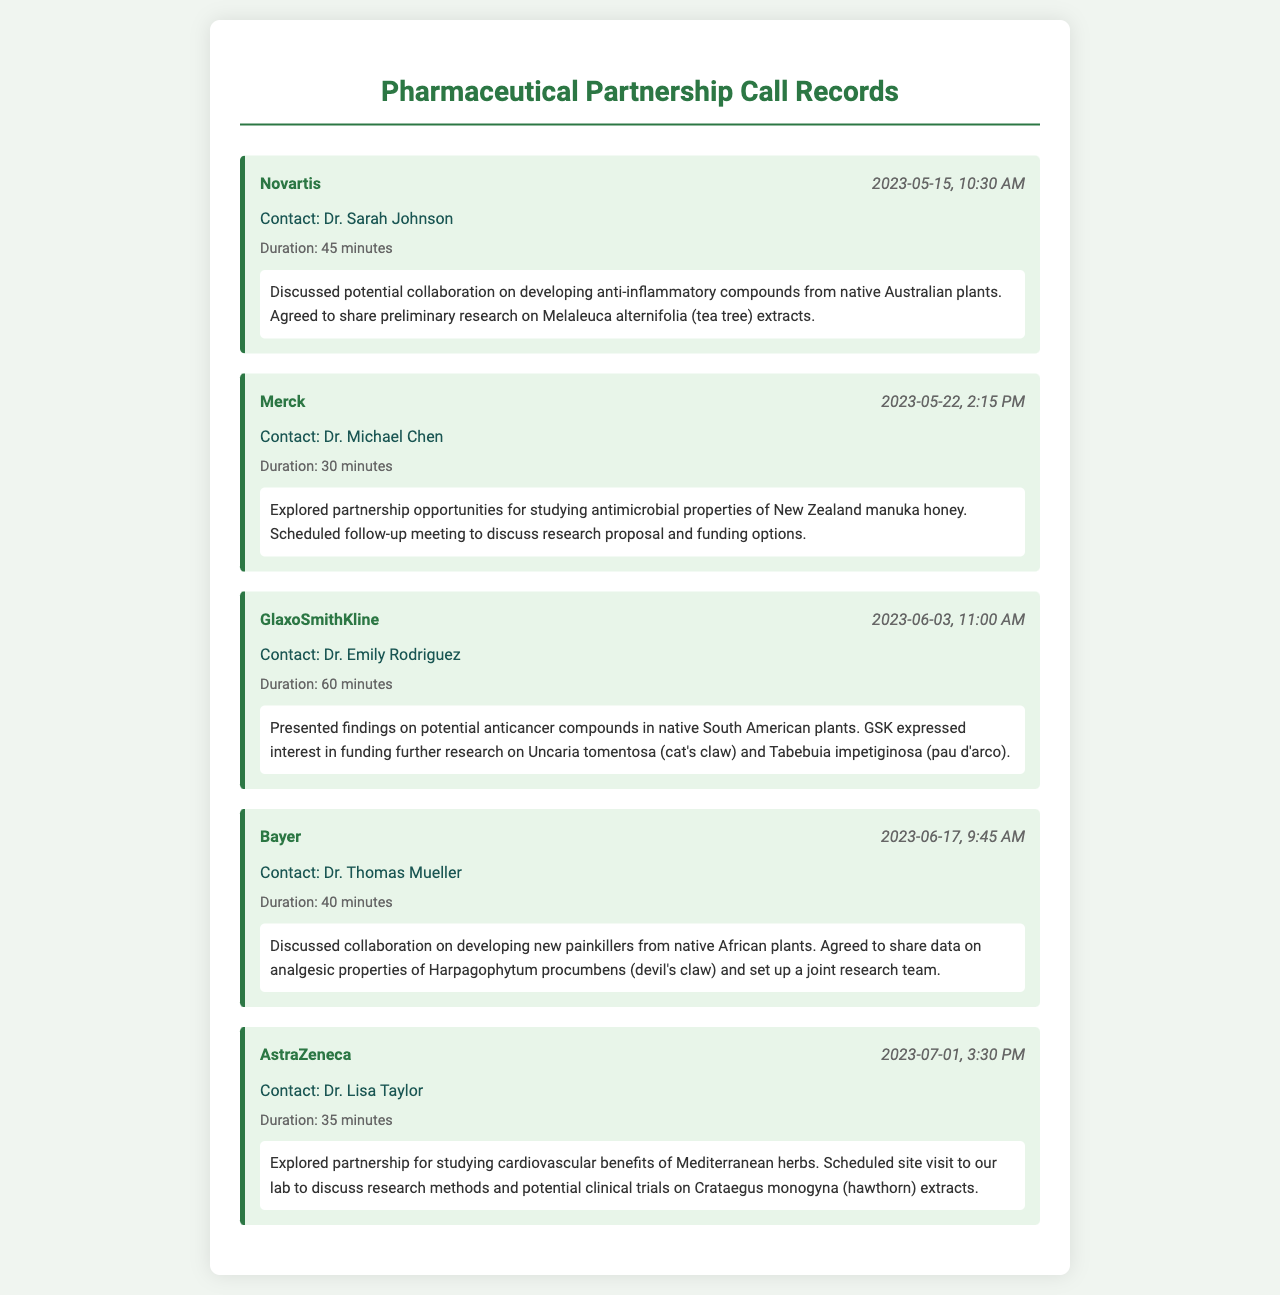What company was contacted on May 15, 2023? The call record indicates that Novartis was contacted on this date.
Answer: Novartis Who is the contact person for Merck? The call notes mention Dr. Michael Chen as the contact for Merck.
Answer: Dr. Michael Chen What was discussed during the call with GlaxoSmithKline? The notes state that potential anticancer compounds in native South American plants were presented during the discussion.
Answer: Anticancer compounds How long was the call with Bayer? The duration of the call with Bayer was explicitly mentioned as 40 minutes.
Answer: 40 minutes What plant was mentioned in relation to the partnership with AstraZeneca? The document refers to Crataegus monogyna, or hawthorn, in the context of studying cardiovascular benefits.
Answer: Crataegus monogyna How many minutes was the call with Novartis? The duration of the call with Novartis was noted to be 45 minutes.
Answer: 45 minutes What type of research was discussed with the contact from Bayer? The discussion focused on developing new painkillers from native African plants, reflecting a specific type of research.
Answer: Painkillers When was the follow-up meeting scheduled with Merck? The document does not specify the exact date of the follow-up meeting but indicates it was scheduled after the discussion.
Answer: Follow-up meeting scheduled 